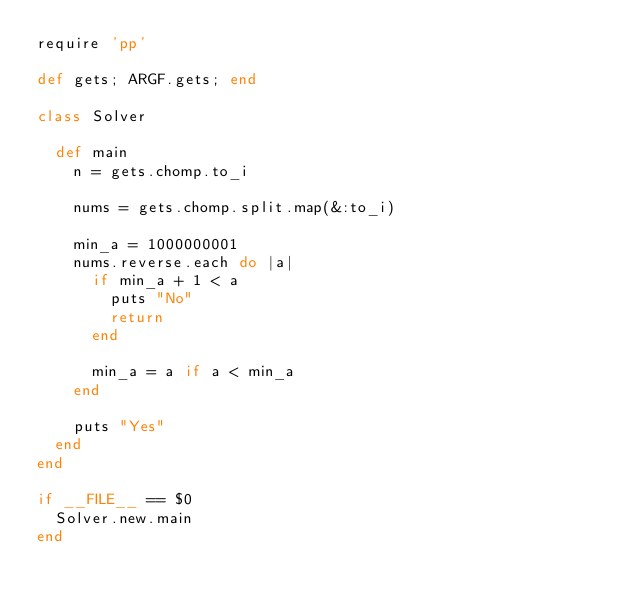Convert code to text. <code><loc_0><loc_0><loc_500><loc_500><_Ruby_>require 'pp'

def gets; ARGF.gets; end

class Solver

  def main
    n = gets.chomp.to_i

    nums = gets.chomp.split.map(&:to_i)

    min_a = 1000000001
    nums.reverse.each do |a|
      if min_a + 1 < a
        puts "No"
        return
      end

      min_a = a if a < min_a
    end

    puts "Yes"
  end
end

if __FILE__ == $0
  Solver.new.main
end
</code> 